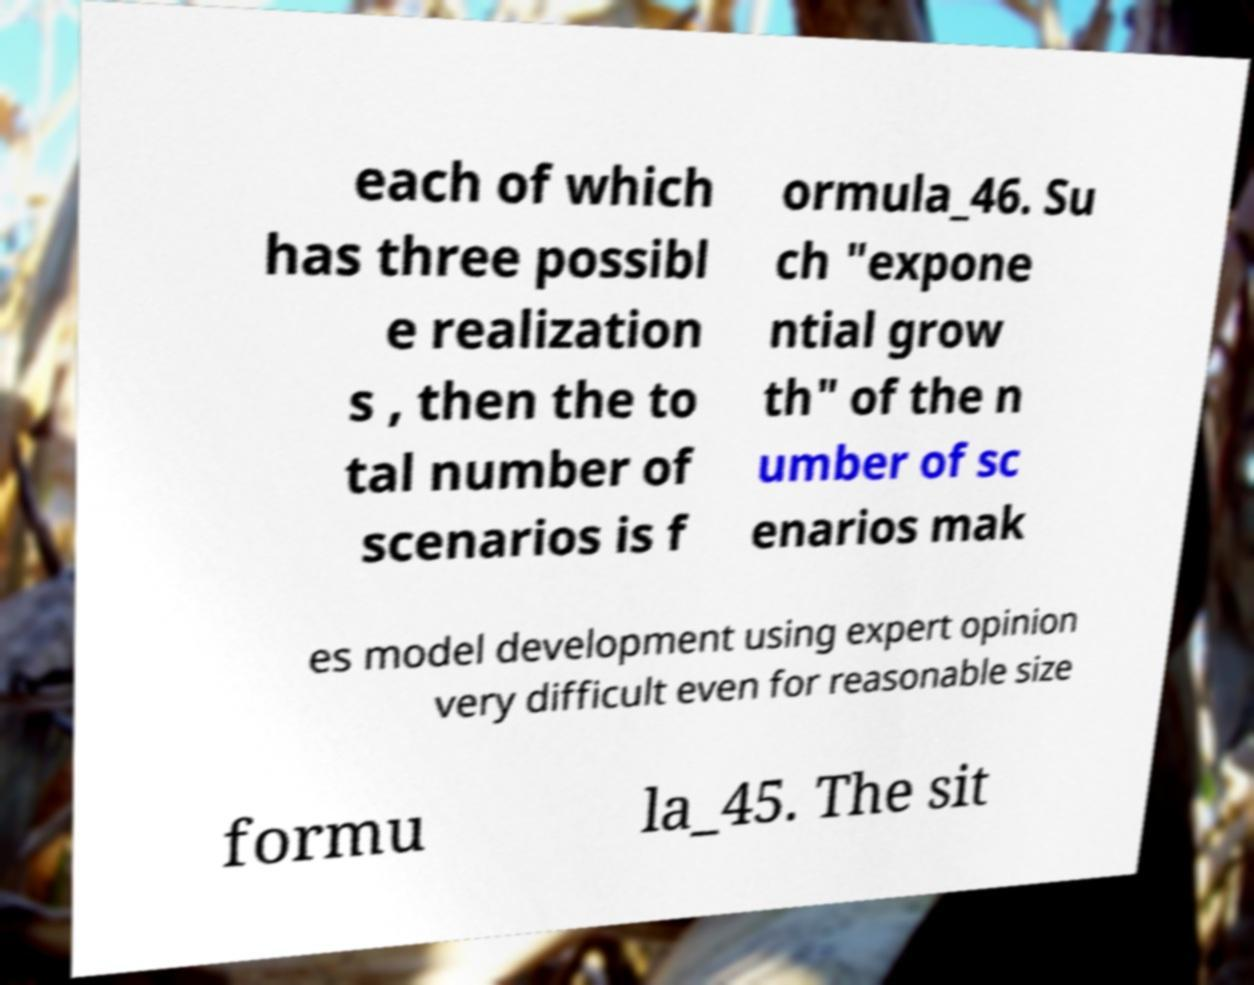Please identify and transcribe the text found in this image. each of which has three possibl e realization s , then the to tal number of scenarios is f ormula_46. Su ch "expone ntial grow th" of the n umber of sc enarios mak es model development using expert opinion very difficult even for reasonable size formu la_45. The sit 